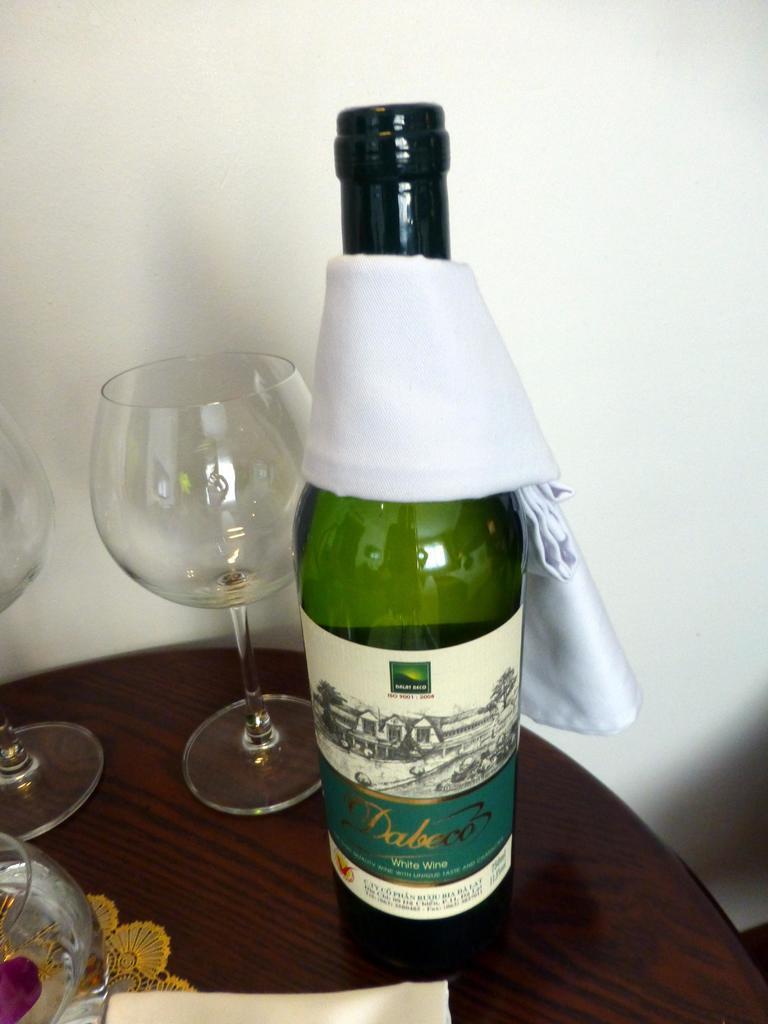Can you describe this image briefly? This image consists of a table. On that table there is a napkin in the bottom, glasses and bottle in the middle. Bottle is in green color. A cloth is there on the bottle. 